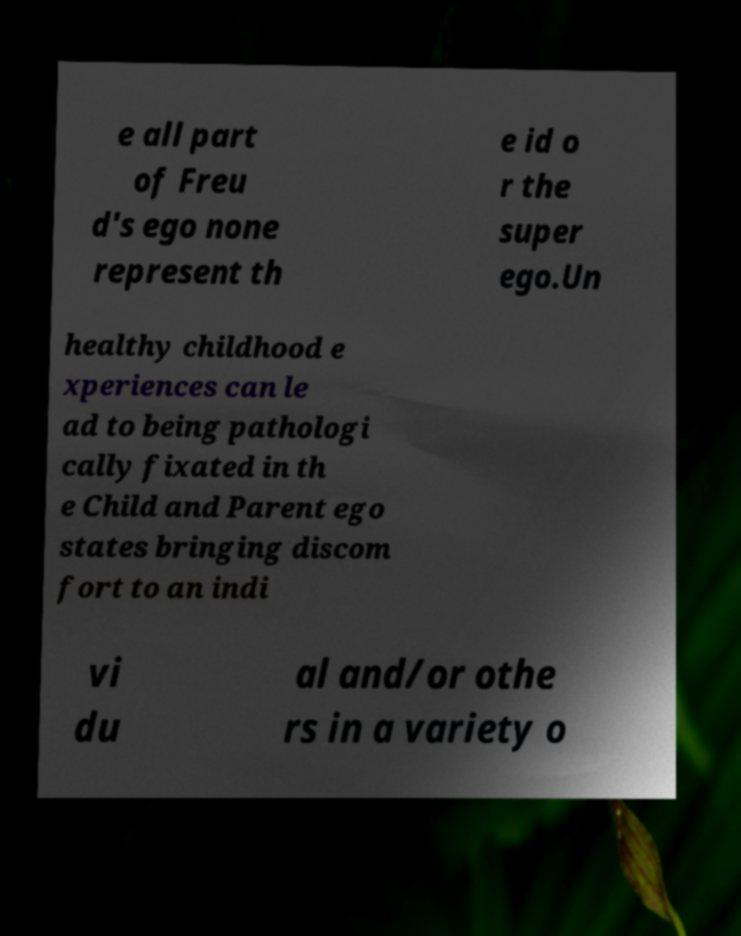Could you assist in decoding the text presented in this image and type it out clearly? e all part of Freu d's ego none represent th e id o r the super ego.Un healthy childhood e xperiences can le ad to being pathologi cally fixated in th e Child and Parent ego states bringing discom fort to an indi vi du al and/or othe rs in a variety o 